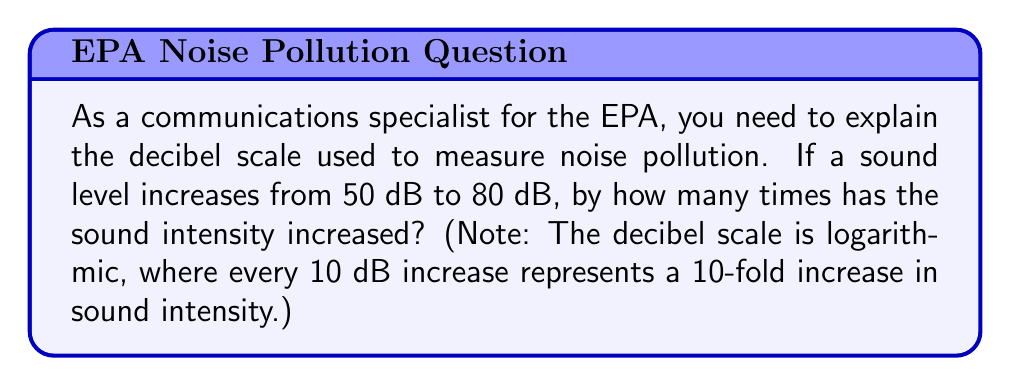Could you help me with this problem? To solve this problem, we need to understand the logarithmic nature of the decibel scale:

1) The decibel (dB) scale is defined as:
   $$ L = 10 \log_{10}\left(\frac{I}{I_0}\right) $$
   where $L$ is the sound level in dB, $I$ is the sound intensity, and $I_0$ is a reference intensity.

2) We're told that every 10 dB increase represents a 10-fold increase in intensity. Let's verify this:
   If $L_2 - L_1 = 10$, then:
   $$ 10 = 10 \log_{10}\left(\frac{I_2}{I_1}\right) $$
   $$ 1 = \log_{10}\left(\frac{I_2}{I_1}\right) $$
   $$ 10^1 = \frac{I_2}{I_1} $$
   $$ \frac{I_2}{I_1} = 10 $$

3) In our problem, the increase is 30 dB (from 50 dB to 80 dB).

4) If 10 dB represents a 10-fold increase, then 30 dB represents:
   $$ 10 \times 10 \times 10 = 10^3 = 1000 $$

Therefore, the sound intensity has increased by a factor of 1000.
Answer: The sound intensity has increased by 1000 times. 